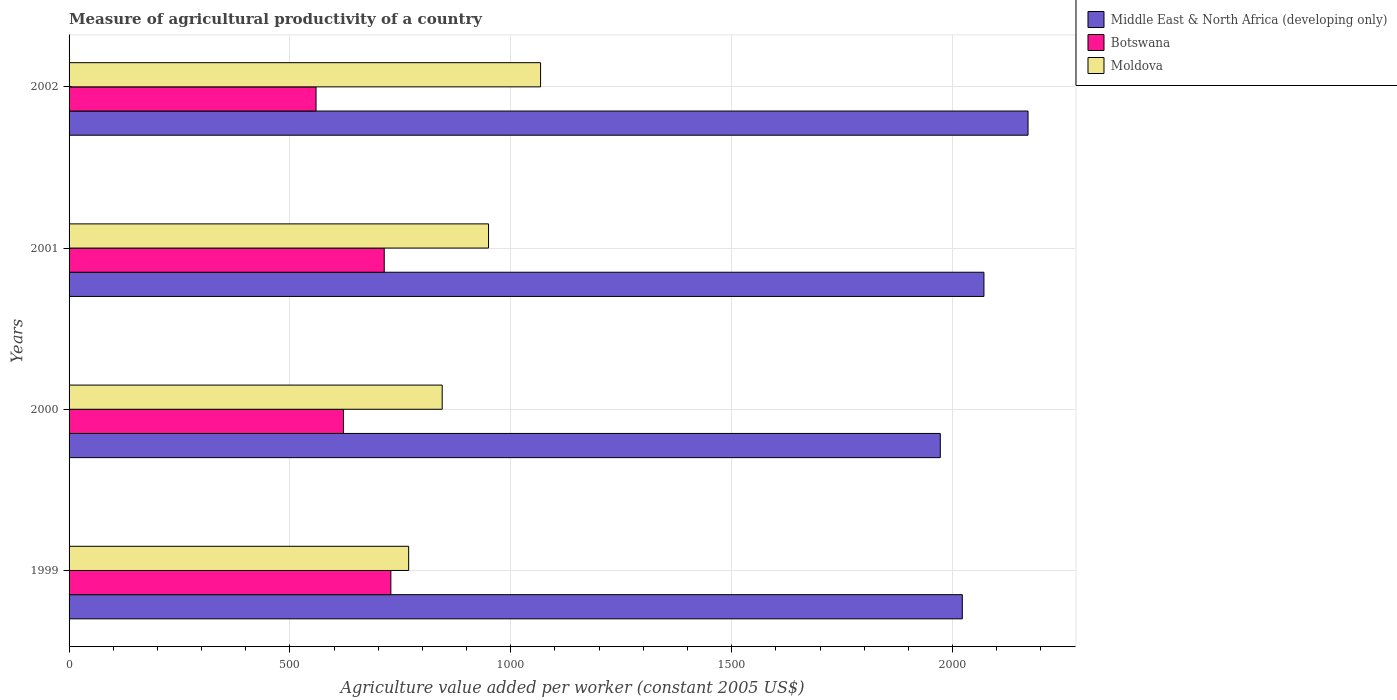How many different coloured bars are there?
Your answer should be very brief. 3. How many groups of bars are there?
Your response must be concise. 4. Are the number of bars per tick equal to the number of legend labels?
Keep it short and to the point. Yes. Are the number of bars on each tick of the Y-axis equal?
Offer a very short reply. Yes. How many bars are there on the 4th tick from the bottom?
Provide a short and direct response. 3. What is the label of the 3rd group of bars from the top?
Your answer should be very brief. 2000. In how many cases, is the number of bars for a given year not equal to the number of legend labels?
Keep it short and to the point. 0. What is the measure of agricultural productivity in Moldova in 2002?
Ensure brevity in your answer.  1067.4. Across all years, what is the maximum measure of agricultural productivity in Middle East & North Africa (developing only)?
Keep it short and to the point. 2170.88. Across all years, what is the minimum measure of agricultural productivity in Moldova?
Your answer should be very brief. 768.76. In which year was the measure of agricultural productivity in Moldova maximum?
Your answer should be very brief. 2002. In which year was the measure of agricultural productivity in Moldova minimum?
Provide a succinct answer. 1999. What is the total measure of agricultural productivity in Moldova in the graph?
Your answer should be compact. 3630.44. What is the difference between the measure of agricultural productivity in Middle East & North Africa (developing only) in 1999 and that in 2002?
Your answer should be compact. -148.76. What is the difference between the measure of agricultural productivity in Middle East & North Africa (developing only) in 2000 and the measure of agricultural productivity in Moldova in 2002?
Your answer should be compact. 904.85. What is the average measure of agricultural productivity in Botswana per year?
Provide a short and direct response. 655.54. In the year 1999, what is the difference between the measure of agricultural productivity in Moldova and measure of agricultural productivity in Botswana?
Provide a succinct answer. 40.3. What is the ratio of the measure of agricultural productivity in Botswana in 2000 to that in 2001?
Offer a terse response. 0.87. Is the difference between the measure of agricultural productivity in Moldova in 1999 and 2000 greater than the difference between the measure of agricultural productivity in Botswana in 1999 and 2000?
Your answer should be very brief. No. What is the difference between the highest and the second highest measure of agricultural productivity in Moldova?
Your answer should be compact. 117.84. What is the difference between the highest and the lowest measure of agricultural productivity in Moldova?
Provide a short and direct response. 298.64. In how many years, is the measure of agricultural productivity in Botswana greater than the average measure of agricultural productivity in Botswana taken over all years?
Offer a terse response. 2. Is the sum of the measure of agricultural productivity in Botswana in 1999 and 2002 greater than the maximum measure of agricultural productivity in Middle East & North Africa (developing only) across all years?
Your answer should be very brief. No. What does the 2nd bar from the top in 2002 represents?
Provide a short and direct response. Botswana. What does the 3rd bar from the bottom in 2000 represents?
Give a very brief answer. Moldova. Is it the case that in every year, the sum of the measure of agricultural productivity in Moldova and measure of agricultural productivity in Middle East & North Africa (developing only) is greater than the measure of agricultural productivity in Botswana?
Keep it short and to the point. Yes. How many bars are there?
Keep it short and to the point. 12. How are the legend labels stacked?
Ensure brevity in your answer.  Vertical. What is the title of the graph?
Your response must be concise. Measure of agricultural productivity of a country. Does "Georgia" appear as one of the legend labels in the graph?
Your answer should be compact. No. What is the label or title of the X-axis?
Your answer should be very brief. Agriculture value added per worker (constant 2005 US$). What is the Agriculture value added per worker (constant 2005 US$) in Middle East & North Africa (developing only) in 1999?
Offer a very short reply. 2022.12. What is the Agriculture value added per worker (constant 2005 US$) of Botswana in 1999?
Your answer should be very brief. 728.46. What is the Agriculture value added per worker (constant 2005 US$) in Moldova in 1999?
Provide a short and direct response. 768.76. What is the Agriculture value added per worker (constant 2005 US$) in Middle East & North Africa (developing only) in 2000?
Provide a succinct answer. 1972.26. What is the Agriculture value added per worker (constant 2005 US$) in Botswana in 2000?
Ensure brevity in your answer.  621.12. What is the Agriculture value added per worker (constant 2005 US$) in Moldova in 2000?
Keep it short and to the point. 844.71. What is the Agriculture value added per worker (constant 2005 US$) of Middle East & North Africa (developing only) in 2001?
Your answer should be compact. 2071.08. What is the Agriculture value added per worker (constant 2005 US$) in Botswana in 2001?
Your answer should be compact. 713.47. What is the Agriculture value added per worker (constant 2005 US$) of Moldova in 2001?
Keep it short and to the point. 949.57. What is the Agriculture value added per worker (constant 2005 US$) of Middle East & North Africa (developing only) in 2002?
Keep it short and to the point. 2170.88. What is the Agriculture value added per worker (constant 2005 US$) in Botswana in 2002?
Your answer should be very brief. 559.09. What is the Agriculture value added per worker (constant 2005 US$) of Moldova in 2002?
Provide a succinct answer. 1067.4. Across all years, what is the maximum Agriculture value added per worker (constant 2005 US$) of Middle East & North Africa (developing only)?
Provide a short and direct response. 2170.88. Across all years, what is the maximum Agriculture value added per worker (constant 2005 US$) of Botswana?
Provide a succinct answer. 728.46. Across all years, what is the maximum Agriculture value added per worker (constant 2005 US$) in Moldova?
Offer a terse response. 1067.4. Across all years, what is the minimum Agriculture value added per worker (constant 2005 US$) of Middle East & North Africa (developing only)?
Make the answer very short. 1972.26. Across all years, what is the minimum Agriculture value added per worker (constant 2005 US$) in Botswana?
Keep it short and to the point. 559.09. Across all years, what is the minimum Agriculture value added per worker (constant 2005 US$) of Moldova?
Give a very brief answer. 768.76. What is the total Agriculture value added per worker (constant 2005 US$) of Middle East & North Africa (developing only) in the graph?
Give a very brief answer. 8236.33. What is the total Agriculture value added per worker (constant 2005 US$) in Botswana in the graph?
Ensure brevity in your answer.  2622.15. What is the total Agriculture value added per worker (constant 2005 US$) of Moldova in the graph?
Your answer should be compact. 3630.44. What is the difference between the Agriculture value added per worker (constant 2005 US$) in Middle East & North Africa (developing only) in 1999 and that in 2000?
Offer a very short reply. 49.86. What is the difference between the Agriculture value added per worker (constant 2005 US$) in Botswana in 1999 and that in 2000?
Give a very brief answer. 107.34. What is the difference between the Agriculture value added per worker (constant 2005 US$) in Moldova in 1999 and that in 2000?
Ensure brevity in your answer.  -75.95. What is the difference between the Agriculture value added per worker (constant 2005 US$) in Middle East & North Africa (developing only) in 1999 and that in 2001?
Provide a short and direct response. -48.96. What is the difference between the Agriculture value added per worker (constant 2005 US$) in Botswana in 1999 and that in 2001?
Give a very brief answer. 14.99. What is the difference between the Agriculture value added per worker (constant 2005 US$) of Moldova in 1999 and that in 2001?
Provide a succinct answer. -180.8. What is the difference between the Agriculture value added per worker (constant 2005 US$) of Middle East & North Africa (developing only) in 1999 and that in 2002?
Make the answer very short. -148.76. What is the difference between the Agriculture value added per worker (constant 2005 US$) in Botswana in 1999 and that in 2002?
Give a very brief answer. 169.37. What is the difference between the Agriculture value added per worker (constant 2005 US$) of Moldova in 1999 and that in 2002?
Provide a short and direct response. -298.64. What is the difference between the Agriculture value added per worker (constant 2005 US$) in Middle East & North Africa (developing only) in 2000 and that in 2001?
Provide a succinct answer. -98.82. What is the difference between the Agriculture value added per worker (constant 2005 US$) of Botswana in 2000 and that in 2001?
Provide a short and direct response. -92.35. What is the difference between the Agriculture value added per worker (constant 2005 US$) of Moldova in 2000 and that in 2001?
Keep it short and to the point. -104.86. What is the difference between the Agriculture value added per worker (constant 2005 US$) of Middle East & North Africa (developing only) in 2000 and that in 2002?
Your answer should be compact. -198.62. What is the difference between the Agriculture value added per worker (constant 2005 US$) of Botswana in 2000 and that in 2002?
Provide a succinct answer. 62.03. What is the difference between the Agriculture value added per worker (constant 2005 US$) of Moldova in 2000 and that in 2002?
Ensure brevity in your answer.  -222.69. What is the difference between the Agriculture value added per worker (constant 2005 US$) in Middle East & North Africa (developing only) in 2001 and that in 2002?
Provide a succinct answer. -99.8. What is the difference between the Agriculture value added per worker (constant 2005 US$) of Botswana in 2001 and that in 2002?
Offer a terse response. 154.38. What is the difference between the Agriculture value added per worker (constant 2005 US$) in Moldova in 2001 and that in 2002?
Your answer should be very brief. -117.84. What is the difference between the Agriculture value added per worker (constant 2005 US$) of Middle East & North Africa (developing only) in 1999 and the Agriculture value added per worker (constant 2005 US$) of Botswana in 2000?
Keep it short and to the point. 1400.99. What is the difference between the Agriculture value added per worker (constant 2005 US$) in Middle East & North Africa (developing only) in 1999 and the Agriculture value added per worker (constant 2005 US$) in Moldova in 2000?
Your answer should be compact. 1177.41. What is the difference between the Agriculture value added per worker (constant 2005 US$) in Botswana in 1999 and the Agriculture value added per worker (constant 2005 US$) in Moldova in 2000?
Give a very brief answer. -116.25. What is the difference between the Agriculture value added per worker (constant 2005 US$) in Middle East & North Africa (developing only) in 1999 and the Agriculture value added per worker (constant 2005 US$) in Botswana in 2001?
Give a very brief answer. 1308.65. What is the difference between the Agriculture value added per worker (constant 2005 US$) in Middle East & North Africa (developing only) in 1999 and the Agriculture value added per worker (constant 2005 US$) in Moldova in 2001?
Provide a short and direct response. 1072.55. What is the difference between the Agriculture value added per worker (constant 2005 US$) of Botswana in 1999 and the Agriculture value added per worker (constant 2005 US$) of Moldova in 2001?
Offer a terse response. -221.11. What is the difference between the Agriculture value added per worker (constant 2005 US$) of Middle East & North Africa (developing only) in 1999 and the Agriculture value added per worker (constant 2005 US$) of Botswana in 2002?
Your answer should be very brief. 1463.02. What is the difference between the Agriculture value added per worker (constant 2005 US$) of Middle East & North Africa (developing only) in 1999 and the Agriculture value added per worker (constant 2005 US$) of Moldova in 2002?
Your answer should be compact. 954.72. What is the difference between the Agriculture value added per worker (constant 2005 US$) in Botswana in 1999 and the Agriculture value added per worker (constant 2005 US$) in Moldova in 2002?
Ensure brevity in your answer.  -338.94. What is the difference between the Agriculture value added per worker (constant 2005 US$) in Middle East & North Africa (developing only) in 2000 and the Agriculture value added per worker (constant 2005 US$) in Botswana in 2001?
Your answer should be very brief. 1258.78. What is the difference between the Agriculture value added per worker (constant 2005 US$) in Middle East & North Africa (developing only) in 2000 and the Agriculture value added per worker (constant 2005 US$) in Moldova in 2001?
Make the answer very short. 1022.69. What is the difference between the Agriculture value added per worker (constant 2005 US$) of Botswana in 2000 and the Agriculture value added per worker (constant 2005 US$) of Moldova in 2001?
Your response must be concise. -328.44. What is the difference between the Agriculture value added per worker (constant 2005 US$) in Middle East & North Africa (developing only) in 2000 and the Agriculture value added per worker (constant 2005 US$) in Botswana in 2002?
Offer a terse response. 1413.16. What is the difference between the Agriculture value added per worker (constant 2005 US$) in Middle East & North Africa (developing only) in 2000 and the Agriculture value added per worker (constant 2005 US$) in Moldova in 2002?
Ensure brevity in your answer.  904.85. What is the difference between the Agriculture value added per worker (constant 2005 US$) in Botswana in 2000 and the Agriculture value added per worker (constant 2005 US$) in Moldova in 2002?
Offer a terse response. -446.28. What is the difference between the Agriculture value added per worker (constant 2005 US$) of Middle East & North Africa (developing only) in 2001 and the Agriculture value added per worker (constant 2005 US$) of Botswana in 2002?
Provide a succinct answer. 1511.99. What is the difference between the Agriculture value added per worker (constant 2005 US$) of Middle East & North Africa (developing only) in 2001 and the Agriculture value added per worker (constant 2005 US$) of Moldova in 2002?
Make the answer very short. 1003.68. What is the difference between the Agriculture value added per worker (constant 2005 US$) in Botswana in 2001 and the Agriculture value added per worker (constant 2005 US$) in Moldova in 2002?
Give a very brief answer. -353.93. What is the average Agriculture value added per worker (constant 2005 US$) in Middle East & North Africa (developing only) per year?
Provide a succinct answer. 2059.08. What is the average Agriculture value added per worker (constant 2005 US$) of Botswana per year?
Provide a succinct answer. 655.54. What is the average Agriculture value added per worker (constant 2005 US$) of Moldova per year?
Provide a short and direct response. 907.61. In the year 1999, what is the difference between the Agriculture value added per worker (constant 2005 US$) in Middle East & North Africa (developing only) and Agriculture value added per worker (constant 2005 US$) in Botswana?
Your response must be concise. 1293.66. In the year 1999, what is the difference between the Agriculture value added per worker (constant 2005 US$) of Middle East & North Africa (developing only) and Agriculture value added per worker (constant 2005 US$) of Moldova?
Offer a terse response. 1253.35. In the year 1999, what is the difference between the Agriculture value added per worker (constant 2005 US$) of Botswana and Agriculture value added per worker (constant 2005 US$) of Moldova?
Ensure brevity in your answer.  -40.3. In the year 2000, what is the difference between the Agriculture value added per worker (constant 2005 US$) in Middle East & North Africa (developing only) and Agriculture value added per worker (constant 2005 US$) in Botswana?
Make the answer very short. 1351.13. In the year 2000, what is the difference between the Agriculture value added per worker (constant 2005 US$) of Middle East & North Africa (developing only) and Agriculture value added per worker (constant 2005 US$) of Moldova?
Your answer should be very brief. 1127.55. In the year 2000, what is the difference between the Agriculture value added per worker (constant 2005 US$) in Botswana and Agriculture value added per worker (constant 2005 US$) in Moldova?
Provide a succinct answer. -223.59. In the year 2001, what is the difference between the Agriculture value added per worker (constant 2005 US$) in Middle East & North Africa (developing only) and Agriculture value added per worker (constant 2005 US$) in Botswana?
Keep it short and to the point. 1357.61. In the year 2001, what is the difference between the Agriculture value added per worker (constant 2005 US$) in Middle East & North Africa (developing only) and Agriculture value added per worker (constant 2005 US$) in Moldova?
Offer a terse response. 1121.51. In the year 2001, what is the difference between the Agriculture value added per worker (constant 2005 US$) of Botswana and Agriculture value added per worker (constant 2005 US$) of Moldova?
Keep it short and to the point. -236.09. In the year 2002, what is the difference between the Agriculture value added per worker (constant 2005 US$) in Middle East & North Africa (developing only) and Agriculture value added per worker (constant 2005 US$) in Botswana?
Your answer should be compact. 1611.78. In the year 2002, what is the difference between the Agriculture value added per worker (constant 2005 US$) of Middle East & North Africa (developing only) and Agriculture value added per worker (constant 2005 US$) of Moldova?
Your answer should be compact. 1103.48. In the year 2002, what is the difference between the Agriculture value added per worker (constant 2005 US$) of Botswana and Agriculture value added per worker (constant 2005 US$) of Moldova?
Provide a succinct answer. -508.31. What is the ratio of the Agriculture value added per worker (constant 2005 US$) of Middle East & North Africa (developing only) in 1999 to that in 2000?
Give a very brief answer. 1.03. What is the ratio of the Agriculture value added per worker (constant 2005 US$) of Botswana in 1999 to that in 2000?
Your answer should be very brief. 1.17. What is the ratio of the Agriculture value added per worker (constant 2005 US$) in Moldova in 1999 to that in 2000?
Your response must be concise. 0.91. What is the ratio of the Agriculture value added per worker (constant 2005 US$) in Middle East & North Africa (developing only) in 1999 to that in 2001?
Your response must be concise. 0.98. What is the ratio of the Agriculture value added per worker (constant 2005 US$) of Botswana in 1999 to that in 2001?
Your answer should be compact. 1.02. What is the ratio of the Agriculture value added per worker (constant 2005 US$) of Moldova in 1999 to that in 2001?
Offer a terse response. 0.81. What is the ratio of the Agriculture value added per worker (constant 2005 US$) of Middle East & North Africa (developing only) in 1999 to that in 2002?
Your answer should be very brief. 0.93. What is the ratio of the Agriculture value added per worker (constant 2005 US$) in Botswana in 1999 to that in 2002?
Make the answer very short. 1.3. What is the ratio of the Agriculture value added per worker (constant 2005 US$) in Moldova in 1999 to that in 2002?
Your answer should be very brief. 0.72. What is the ratio of the Agriculture value added per worker (constant 2005 US$) of Middle East & North Africa (developing only) in 2000 to that in 2001?
Your response must be concise. 0.95. What is the ratio of the Agriculture value added per worker (constant 2005 US$) in Botswana in 2000 to that in 2001?
Offer a terse response. 0.87. What is the ratio of the Agriculture value added per worker (constant 2005 US$) in Moldova in 2000 to that in 2001?
Make the answer very short. 0.89. What is the ratio of the Agriculture value added per worker (constant 2005 US$) of Middle East & North Africa (developing only) in 2000 to that in 2002?
Your answer should be compact. 0.91. What is the ratio of the Agriculture value added per worker (constant 2005 US$) in Botswana in 2000 to that in 2002?
Keep it short and to the point. 1.11. What is the ratio of the Agriculture value added per worker (constant 2005 US$) of Moldova in 2000 to that in 2002?
Offer a very short reply. 0.79. What is the ratio of the Agriculture value added per worker (constant 2005 US$) in Middle East & North Africa (developing only) in 2001 to that in 2002?
Offer a very short reply. 0.95. What is the ratio of the Agriculture value added per worker (constant 2005 US$) of Botswana in 2001 to that in 2002?
Ensure brevity in your answer.  1.28. What is the ratio of the Agriculture value added per worker (constant 2005 US$) in Moldova in 2001 to that in 2002?
Make the answer very short. 0.89. What is the difference between the highest and the second highest Agriculture value added per worker (constant 2005 US$) of Middle East & North Africa (developing only)?
Offer a terse response. 99.8. What is the difference between the highest and the second highest Agriculture value added per worker (constant 2005 US$) of Botswana?
Make the answer very short. 14.99. What is the difference between the highest and the second highest Agriculture value added per worker (constant 2005 US$) in Moldova?
Keep it short and to the point. 117.84. What is the difference between the highest and the lowest Agriculture value added per worker (constant 2005 US$) of Middle East & North Africa (developing only)?
Keep it short and to the point. 198.62. What is the difference between the highest and the lowest Agriculture value added per worker (constant 2005 US$) in Botswana?
Provide a short and direct response. 169.37. What is the difference between the highest and the lowest Agriculture value added per worker (constant 2005 US$) in Moldova?
Your answer should be compact. 298.64. 